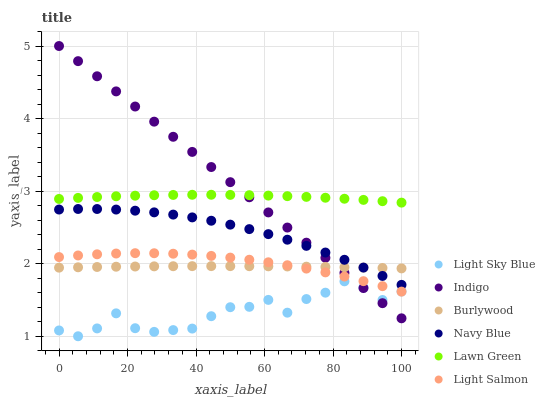Does Light Sky Blue have the minimum area under the curve?
Answer yes or no. Yes. Does Indigo have the maximum area under the curve?
Answer yes or no. Yes. Does Light Salmon have the minimum area under the curve?
Answer yes or no. No. Does Light Salmon have the maximum area under the curve?
Answer yes or no. No. Is Indigo the smoothest?
Answer yes or no. Yes. Is Light Sky Blue the roughest?
Answer yes or no. Yes. Is Light Salmon the smoothest?
Answer yes or no. No. Is Light Salmon the roughest?
Answer yes or no. No. Does Light Sky Blue have the lowest value?
Answer yes or no. Yes. Does Light Salmon have the lowest value?
Answer yes or no. No. Does Indigo have the highest value?
Answer yes or no. Yes. Does Light Salmon have the highest value?
Answer yes or no. No. Is Light Salmon less than Lawn Green?
Answer yes or no. Yes. Is Lawn Green greater than Light Sky Blue?
Answer yes or no. Yes. Does Navy Blue intersect Indigo?
Answer yes or no. Yes. Is Navy Blue less than Indigo?
Answer yes or no. No. Is Navy Blue greater than Indigo?
Answer yes or no. No. Does Light Salmon intersect Lawn Green?
Answer yes or no. No. 